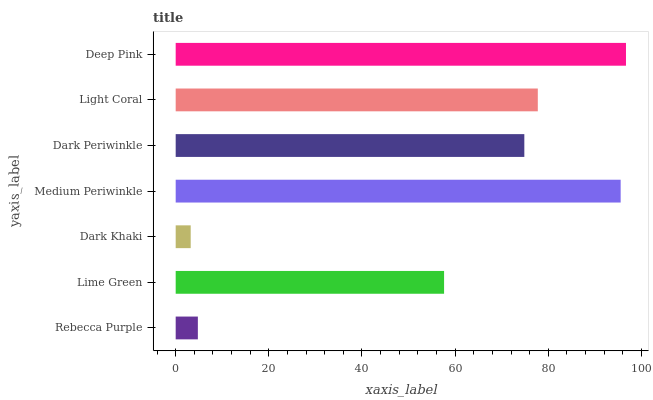Is Dark Khaki the minimum?
Answer yes or no. Yes. Is Deep Pink the maximum?
Answer yes or no. Yes. Is Lime Green the minimum?
Answer yes or no. No. Is Lime Green the maximum?
Answer yes or no. No. Is Lime Green greater than Rebecca Purple?
Answer yes or no. Yes. Is Rebecca Purple less than Lime Green?
Answer yes or no. Yes. Is Rebecca Purple greater than Lime Green?
Answer yes or no. No. Is Lime Green less than Rebecca Purple?
Answer yes or no. No. Is Dark Periwinkle the high median?
Answer yes or no. Yes. Is Dark Periwinkle the low median?
Answer yes or no. Yes. Is Dark Khaki the high median?
Answer yes or no. No. Is Medium Periwinkle the low median?
Answer yes or no. No. 